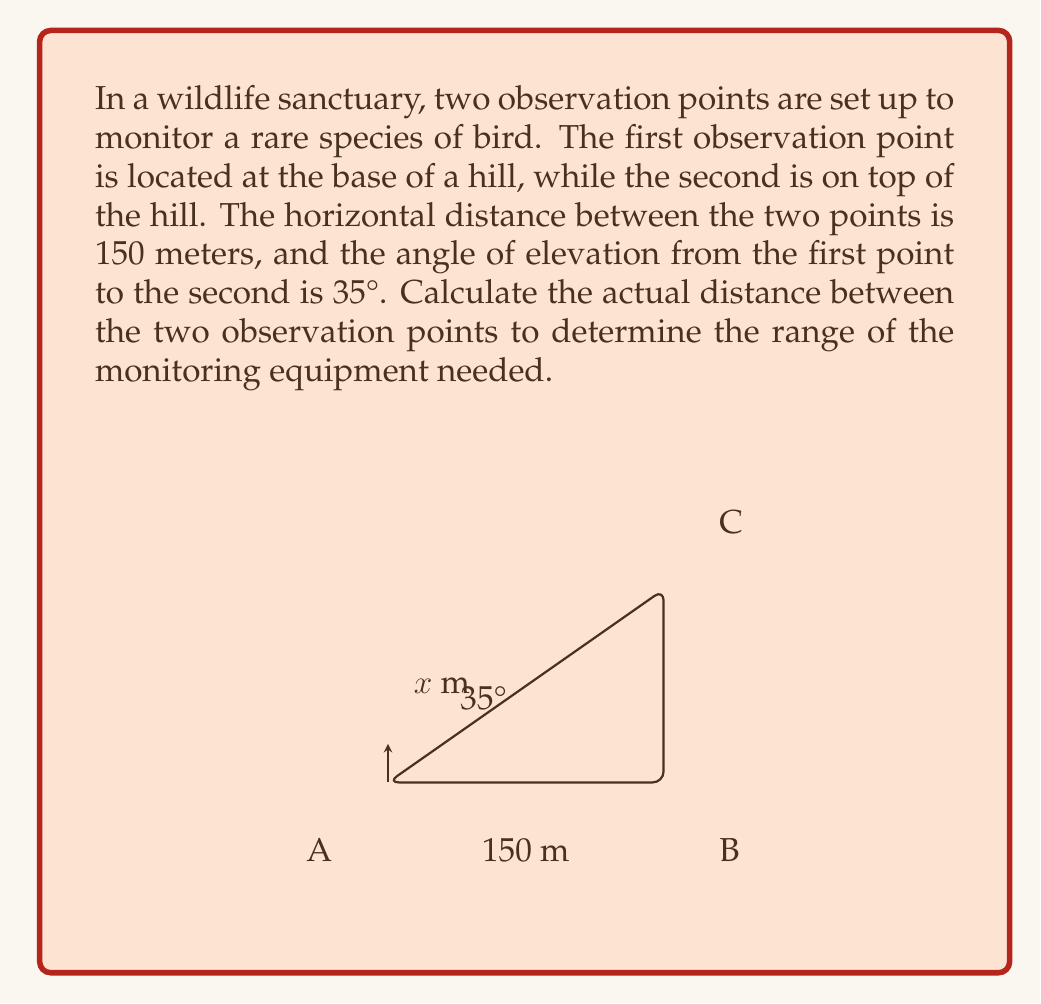Solve this math problem. Let's approach this step-by-step using trigonometry:

1) Let's define our triangle:
   - Point A is the first observation point (at the base of the hill)
   - Point B is directly below the second observation point
   - Point C is the second observation point (on top of the hill)
   - The distance AB is 150 meters
   - The angle at A is 35°
   - Let the distance AC (what we're trying to find) be $x$ meters

2) We can use the tangent function to find the height of the hill:
   $$\tan(35°) = \frac{\text{opposite}}{\text{adjacent}} = \frac{BC}{AB}$$

3) Rearranging this:
   $$BC = AB \cdot \tan(35°) = 150 \cdot \tan(35°) \approx 105.03 \text{ meters}$$

4) Now we have a right-angled triangle where we know two sides:
   - The base (AB) is 150 meters
   - The height (BC) is approximately 105.03 meters

5) We can use the Pythagorean theorem to find the hypotenuse (AC), which is our desired distance:
   $$AC^2 = AB^2 + BC^2$$
   $$x^2 = 150^2 + 105.03^2$$

6) Solving for $x$:
   $$x = \sqrt{150^2 + 105.03^2} \approx 183.01 \text{ meters}$$

Therefore, the actual distance between the two observation points is approximately 183.01 meters.
Answer: $183.01 \text{ meters}$ 